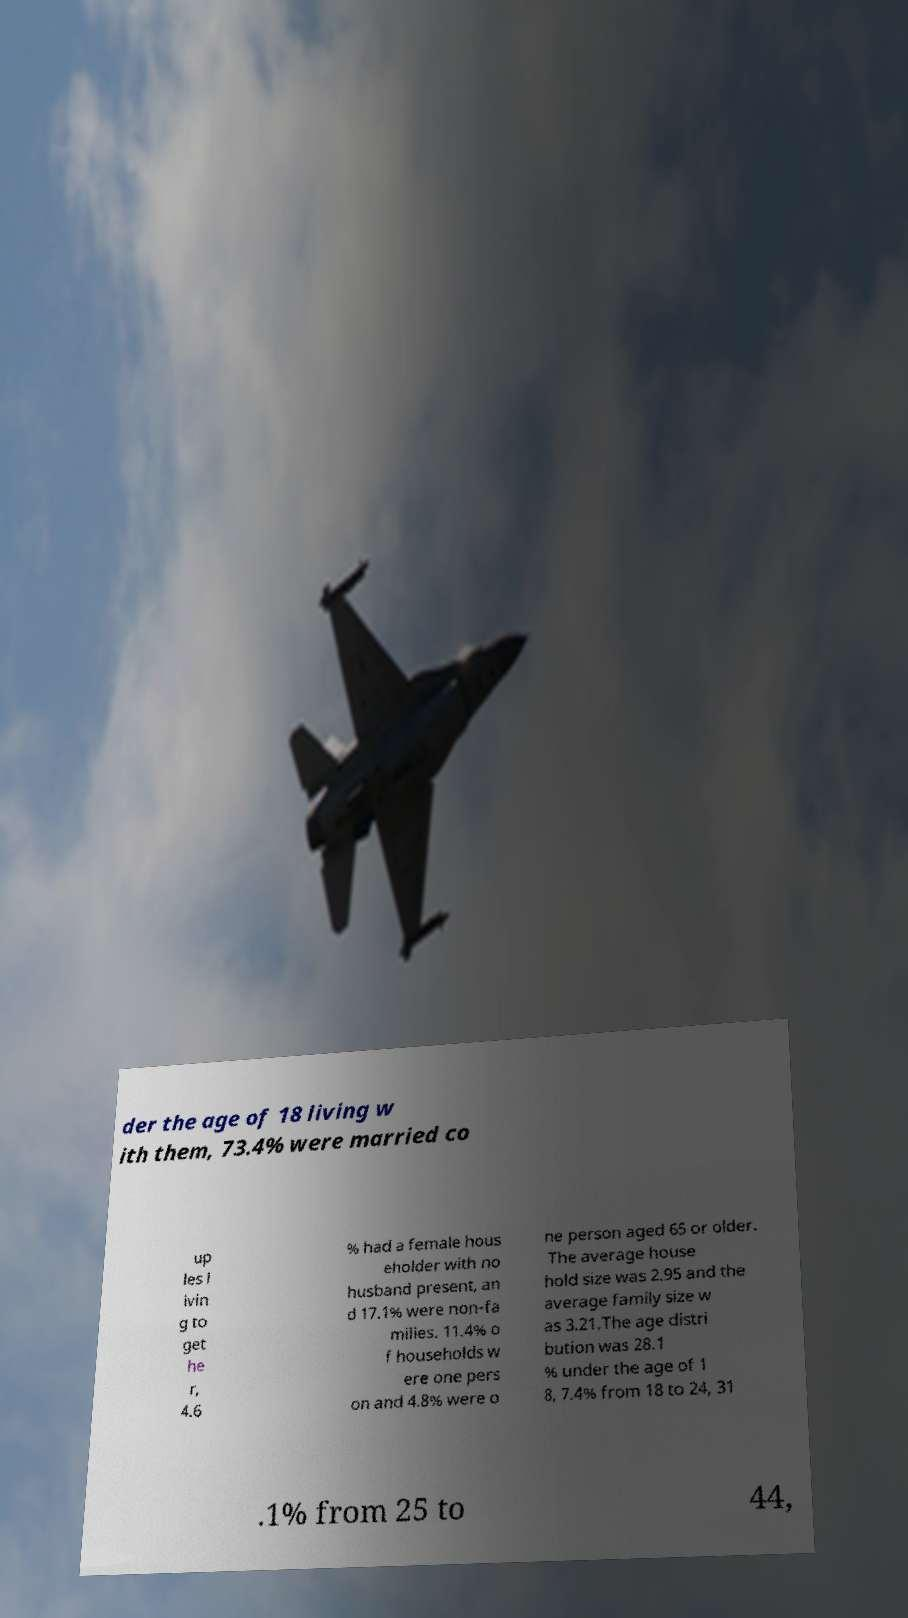Could you extract and type out the text from this image? der the age of 18 living w ith them, 73.4% were married co up les l ivin g to get he r, 4.6 % had a female hous eholder with no husband present, an d 17.1% were non-fa milies. 11.4% o f households w ere one pers on and 4.8% were o ne person aged 65 or older. The average house hold size was 2.95 and the average family size w as 3.21.The age distri bution was 28.1 % under the age of 1 8, 7.4% from 18 to 24, 31 .1% from 25 to 44, 